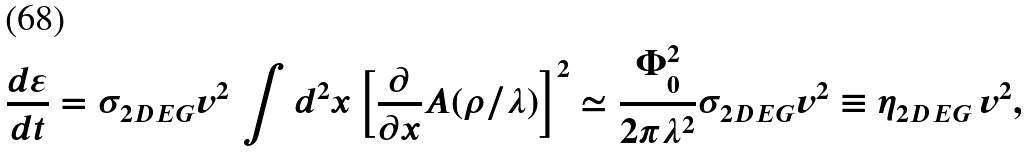<formula> <loc_0><loc_0><loc_500><loc_500>\frac { d \varepsilon } { d t } = \sigma _ { 2 D E G } v ^ { 2 } \, \int d ^ { 2 } x \left [ \frac { \partial } { \partial x } { A } ( \rho / \lambda ) \right ] ^ { 2 } \simeq \frac { \Phi _ { 0 } ^ { 2 } } { 2 \pi \lambda ^ { 2 } } \sigma _ { 2 D E G } v ^ { 2 } \equiv \eta _ { 2 D E G } \, v ^ { 2 } ,</formula> 